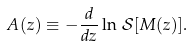Convert formula to latex. <formula><loc_0><loc_0><loc_500><loc_500>A ( z ) \equiv - \frac { d } { d z } \ln \, \mathcal { S } [ M ( z ) ] .</formula> 